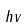<formula> <loc_0><loc_0><loc_500><loc_500>h v</formula> 